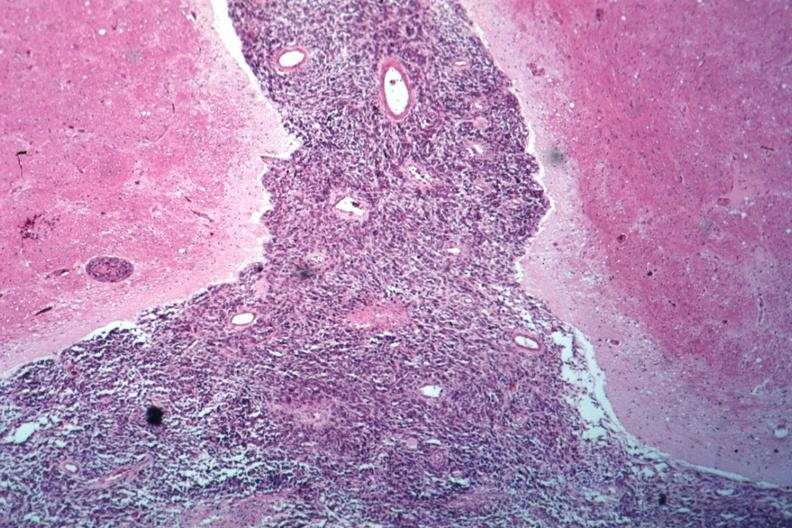does this image show looks like spindle cell tumor filling space well shown primary not known at this time?
Answer the question using a single word or phrase. Yes 